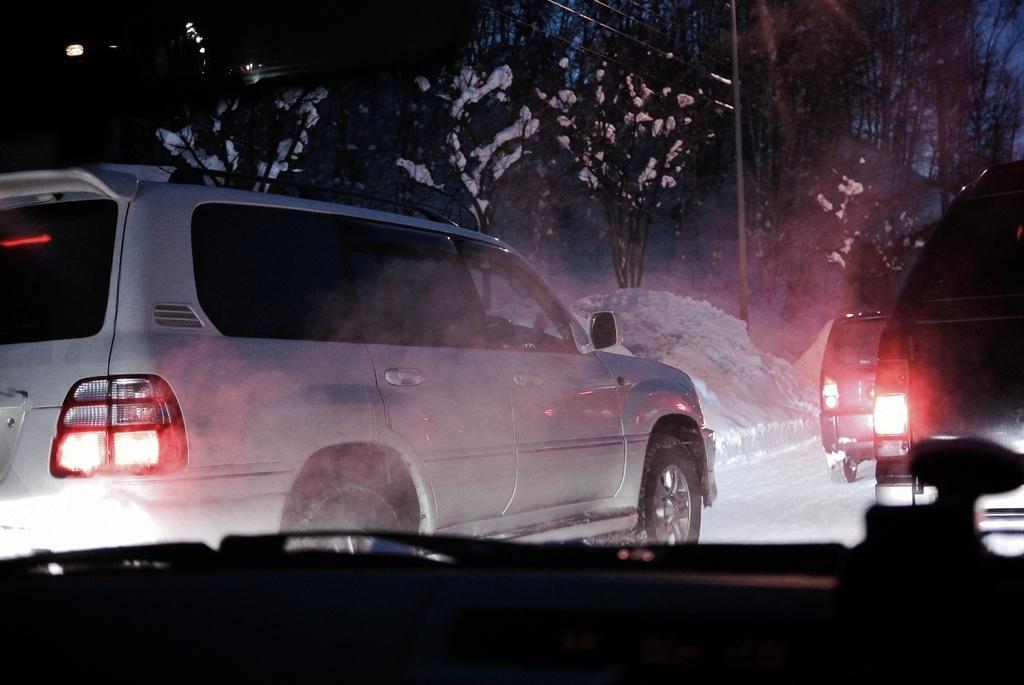Can you describe this image briefly? In this image we can see cars and there is snow. In the background there are trees, wires and sky. 